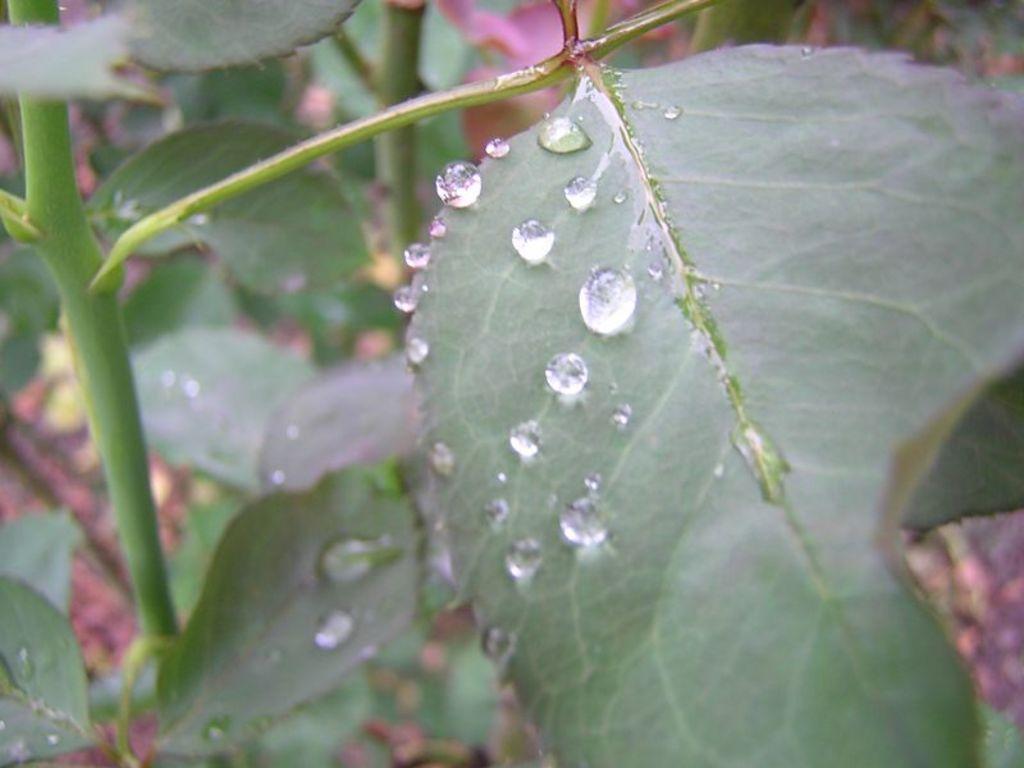Could you give a brief overview of what you see in this image? This looks like a branch with leaves. I can see the water drops on the leaves. 